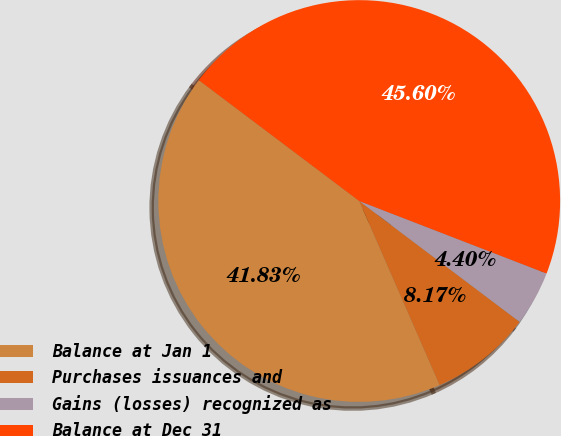Convert chart to OTSL. <chart><loc_0><loc_0><loc_500><loc_500><pie_chart><fcel>Balance at Jan 1<fcel>Purchases issuances and<fcel>Gains (losses) recognized as<fcel>Balance at Dec 31<nl><fcel>41.83%<fcel>8.17%<fcel>4.4%<fcel>45.6%<nl></chart> 